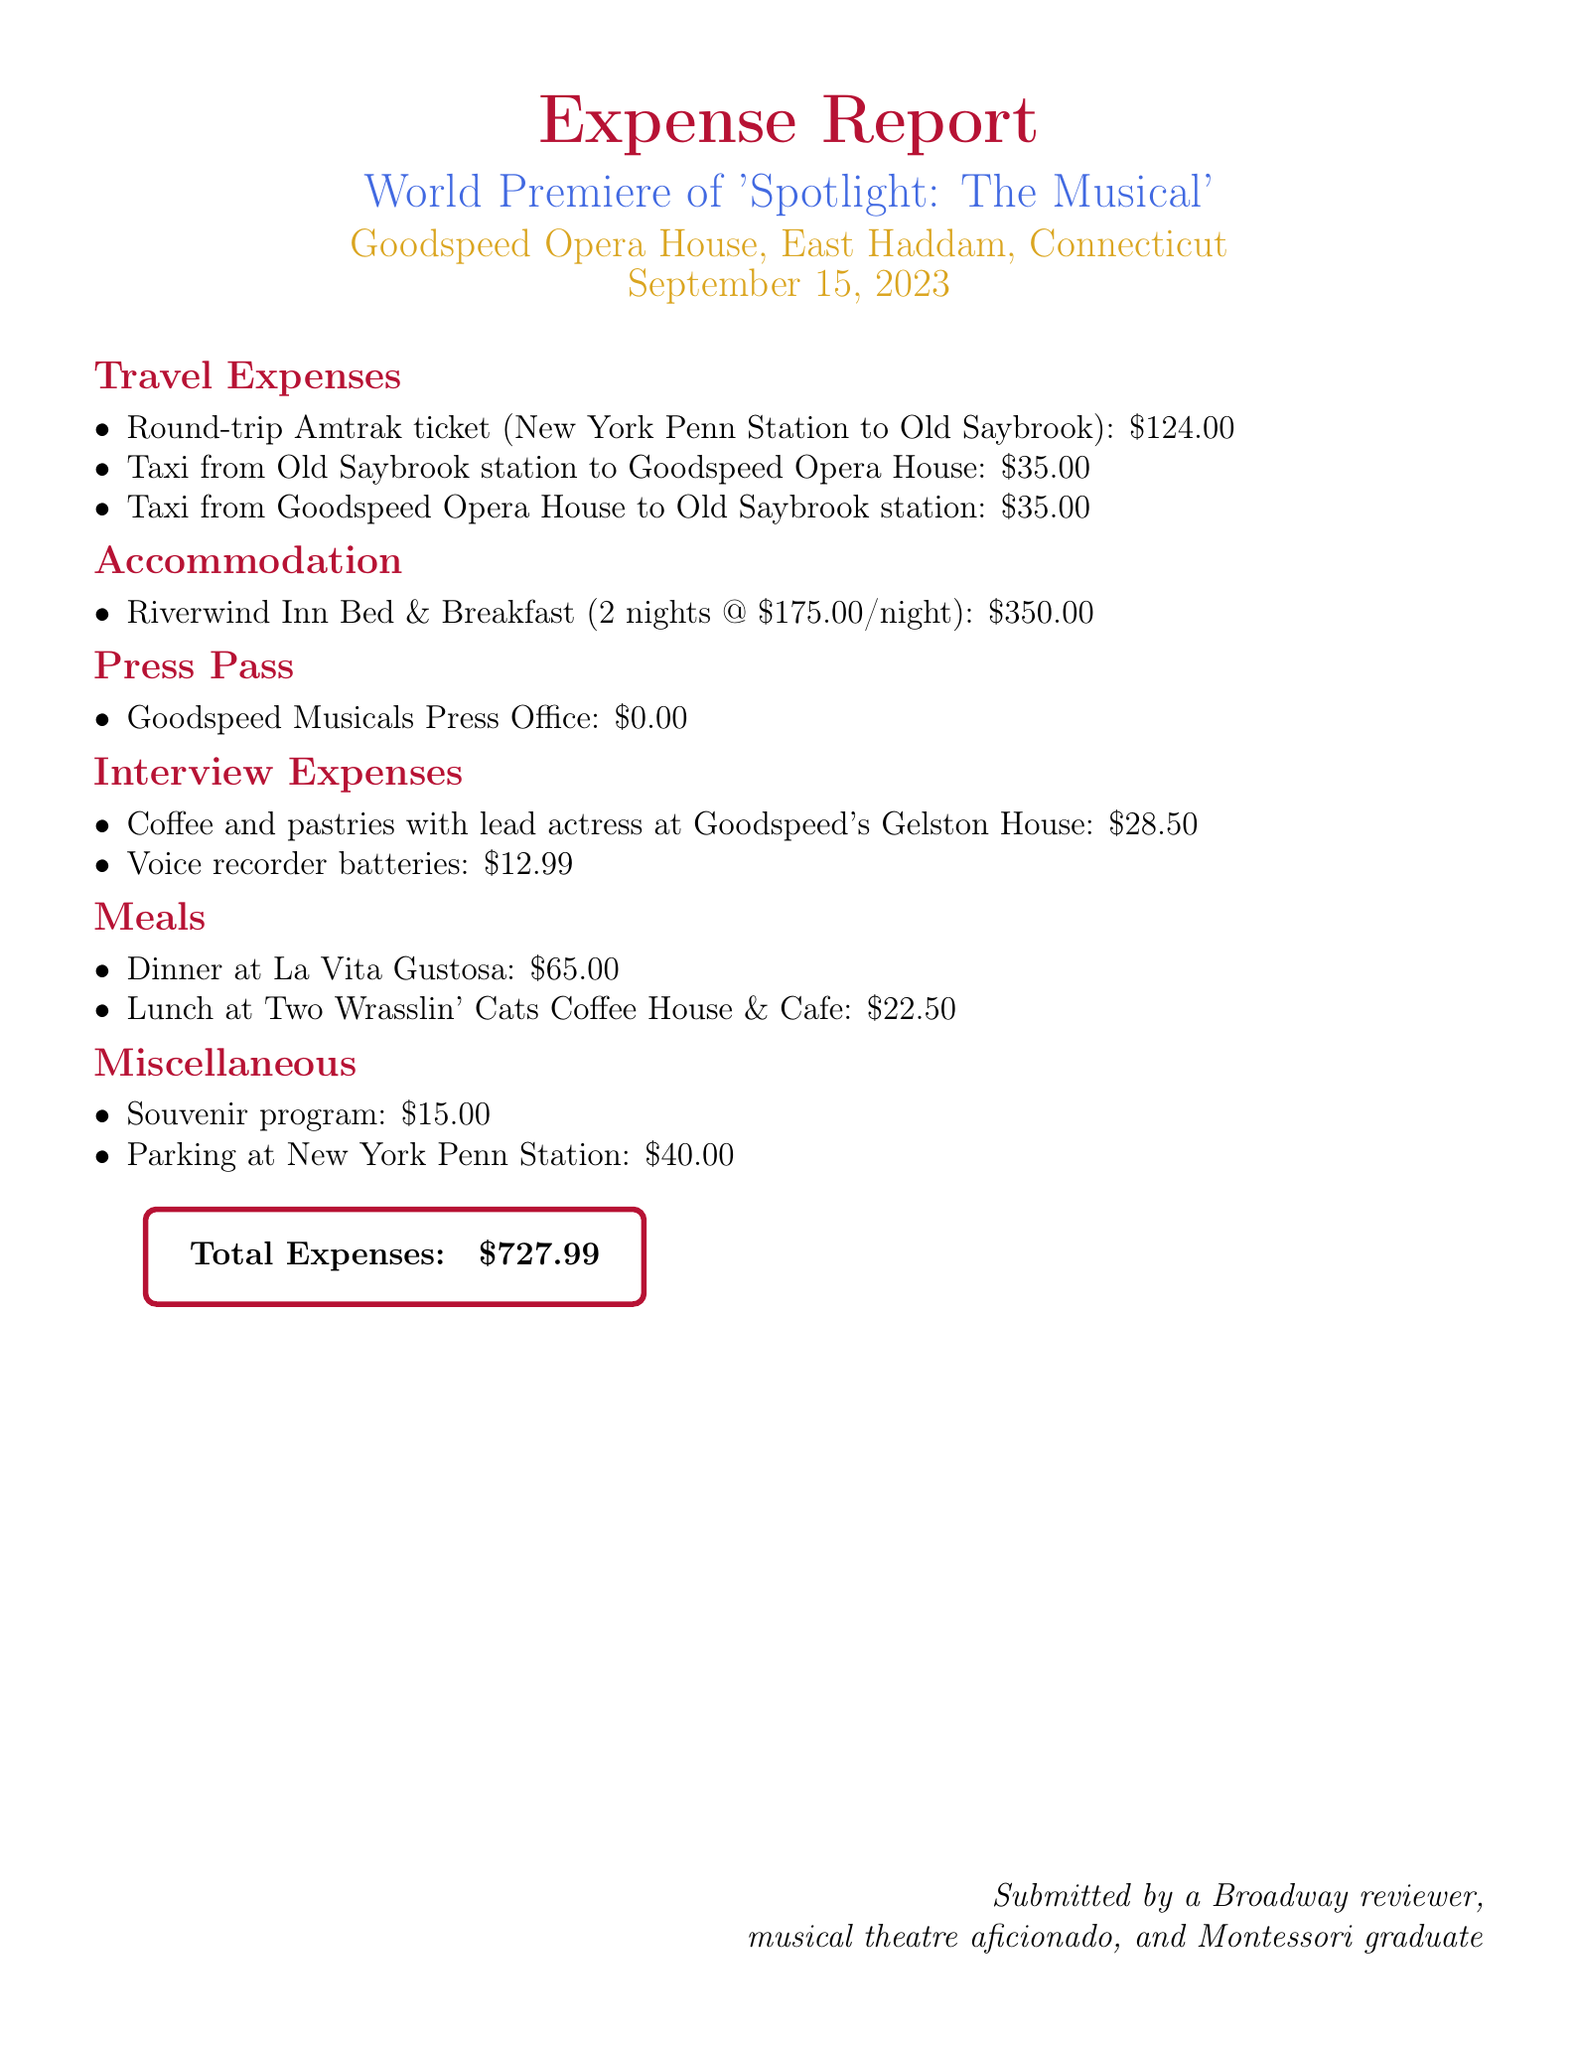What is the total expenses? The total expenses is listed at the bottom of the document.
Answer: $727.99 Where did the premiere take place? The location of the premiere is mentioned in the subtitle of the document.
Answer: Goodspeed Opera House, East Haddam, Connecticut How much was spent on accommodation? The accommodation section details the total amount spent for the nights stayed.
Answer: $350.00 What were the interview expenses? The interview expenses section includes specific items and their costs.
Answer: $41.49 What type of ticket was purchased for travel? The travel expenses section specifies the type of ticket purchased.
Answer: Round-trip Amtrak ticket What is the cost of parking at New York Penn Station? The miscellaneous section provides the amount spent on parking.
Answer: $40.00 How many nights was accommodation booked for? The accommodation section indicates the length of stay.
Answer: 2 nights What is the price of the souvenir program? The miscellaneous section lists the price of the souvenir program.
Answer: $15.00 What date was the musical premiere? The document states the date in the header section.
Answer: September 15, 2023 